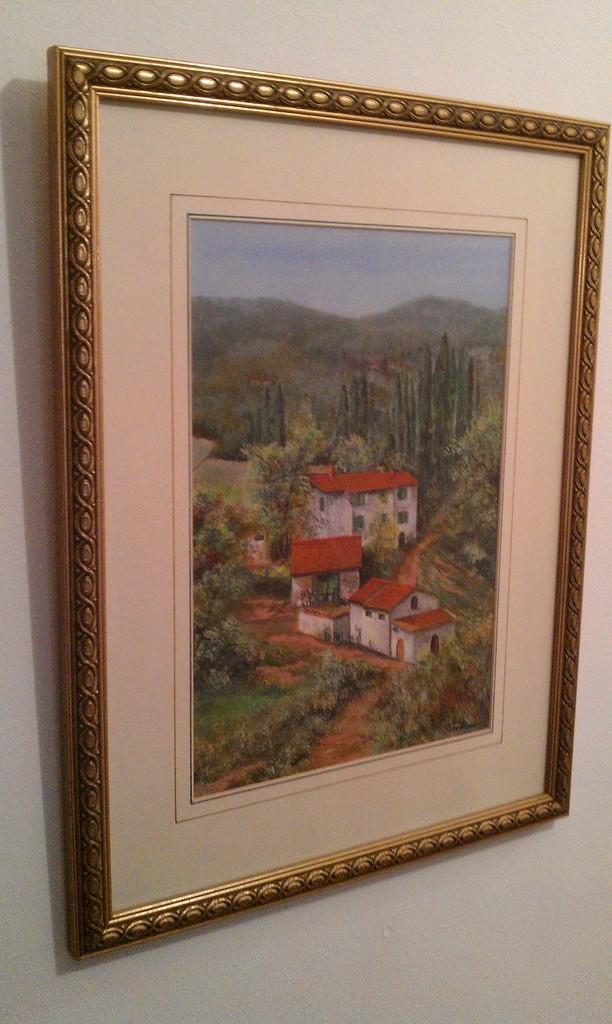In one or two sentences, can you explain what this image depicts? In this picture there is a frame on the wall. On the frame there are pictures of buildings and trees and mountains. At the top there is sky. At the bottom there is grass and there is ground. 